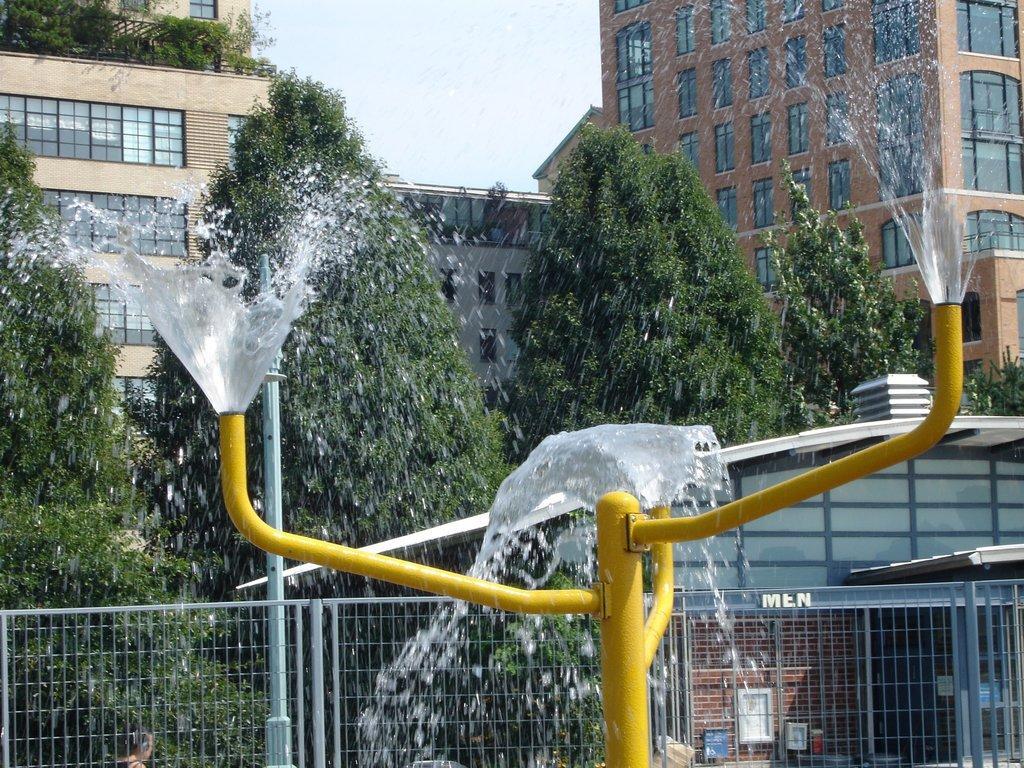In one or two sentences, can you explain what this image depicts? Water is coming from this rods. Background there are buildings with windows and trees. 